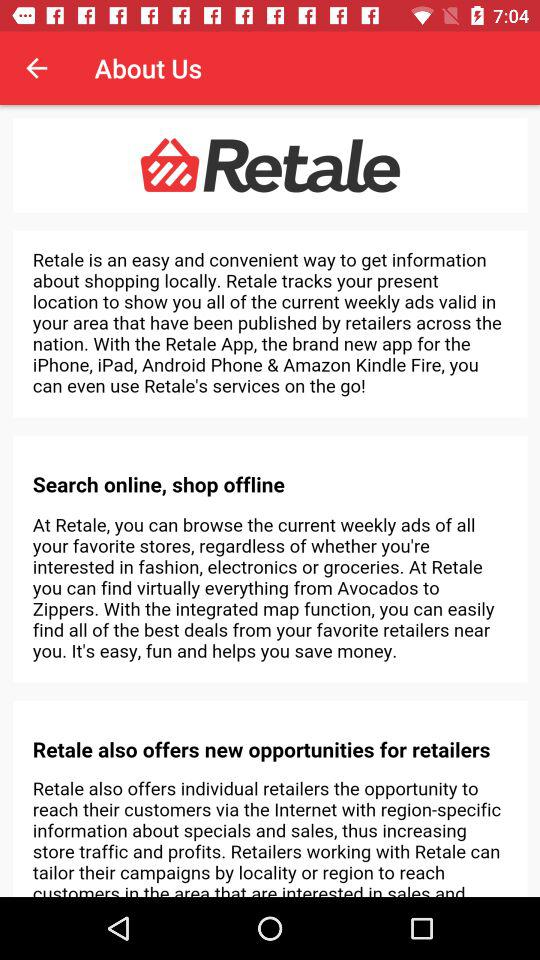What is the name of the application? The name of the application is "Retale". 